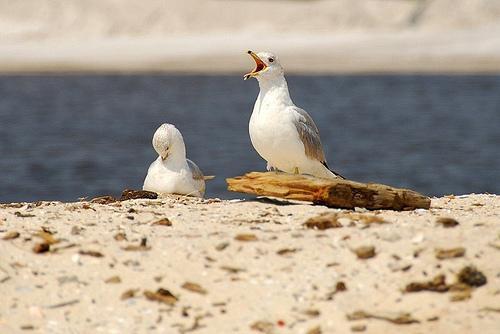How many animals are there?
Give a very brief answer. 2. 